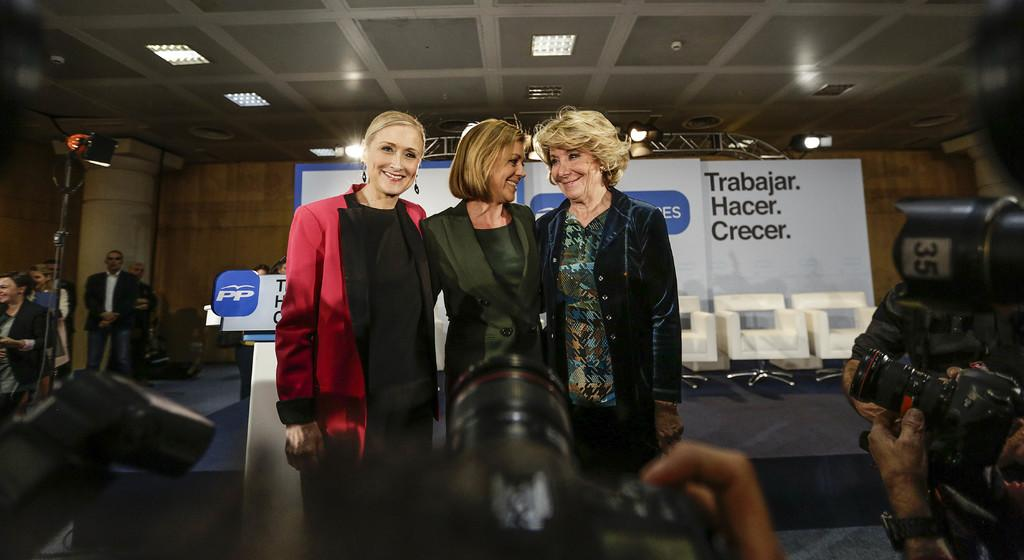How many women are in the image? There are three beautiful women in the image. What are the women doing in the image? The women are standing and smiling. Where are the cameras located in the image? The cameras are at the down side of the image. What type of juice can be seen on the floor in the image? There is no juice present on the floor in the image. How many boys are visible in the image? There are no boys visible in the image; it features three beautiful women. 